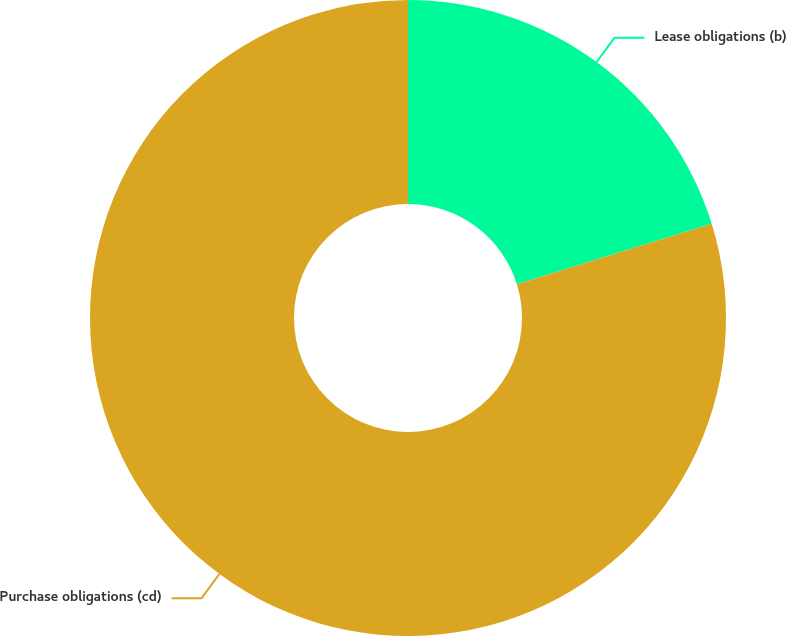Convert chart. <chart><loc_0><loc_0><loc_500><loc_500><pie_chart><fcel>Lease obligations (b)<fcel>Purchase obligations (cd)<nl><fcel>20.21%<fcel>79.79%<nl></chart> 